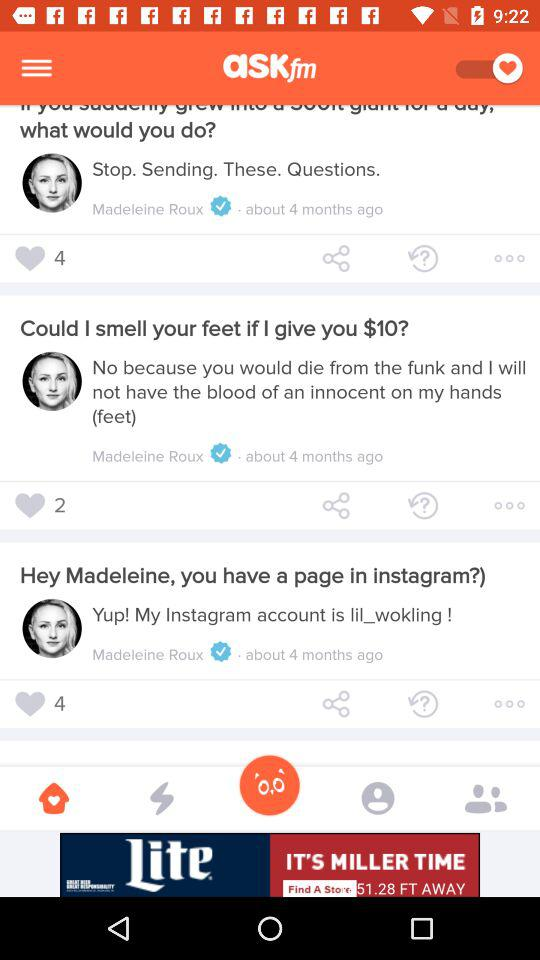How many questions have been asked?
Answer the question using a single word or phrase. 3 